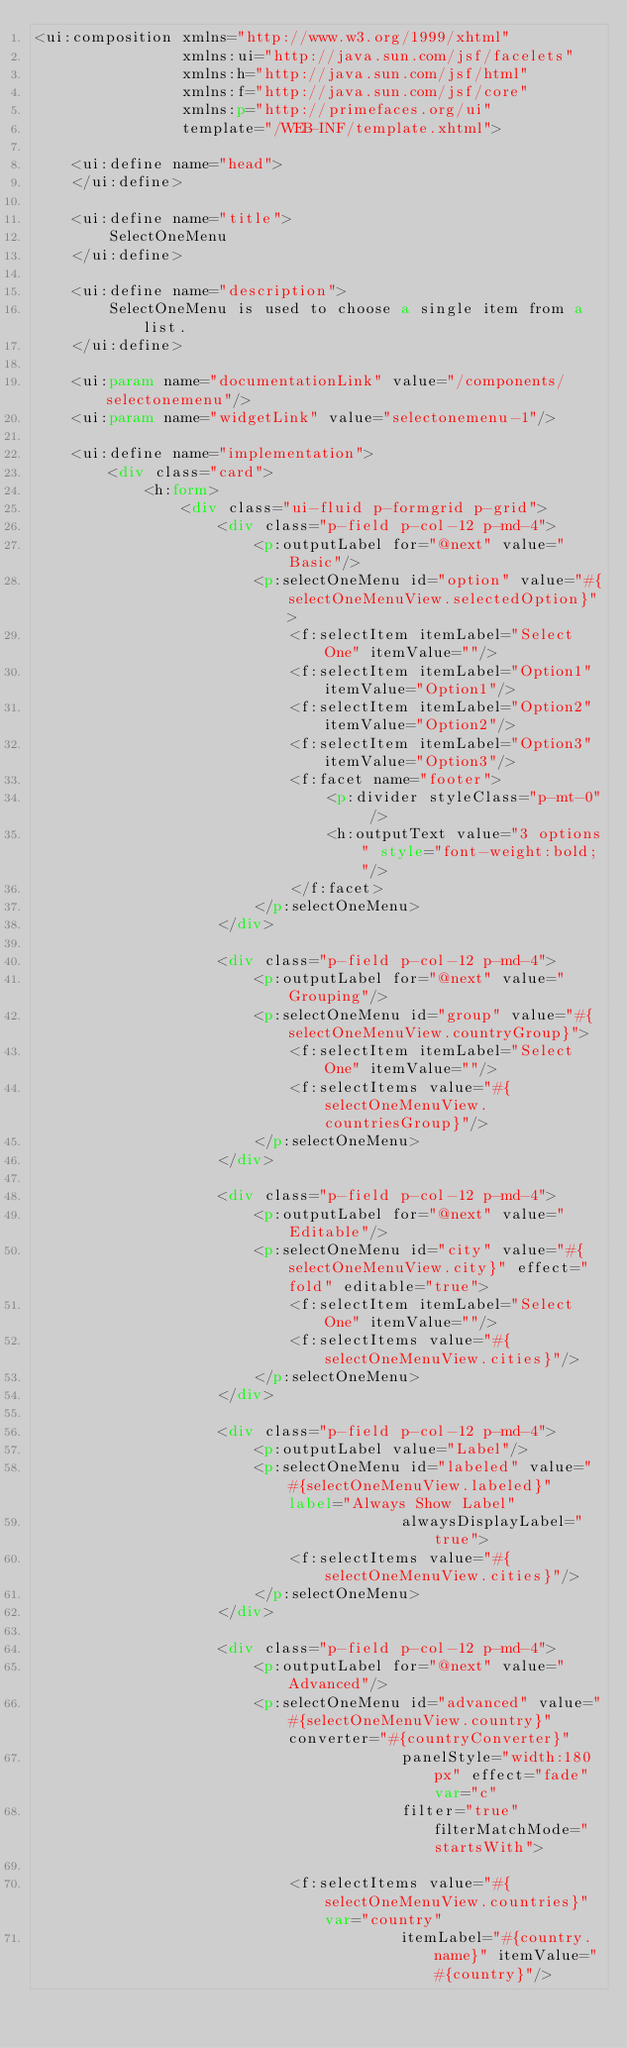Convert code to text. <code><loc_0><loc_0><loc_500><loc_500><_HTML_><ui:composition xmlns="http://www.w3.org/1999/xhtml"
                xmlns:ui="http://java.sun.com/jsf/facelets"
                xmlns:h="http://java.sun.com/jsf/html"
                xmlns:f="http://java.sun.com/jsf/core"
                xmlns:p="http://primefaces.org/ui"
                template="/WEB-INF/template.xhtml">

    <ui:define name="head">
    </ui:define>

    <ui:define name="title">
        SelectOneMenu
    </ui:define>

    <ui:define name="description">
        SelectOneMenu is used to choose a single item from a list.
    </ui:define>

    <ui:param name="documentationLink" value="/components/selectonemenu"/>
    <ui:param name="widgetLink" value="selectonemenu-1"/>

    <ui:define name="implementation">
        <div class="card">
            <h:form>
                <div class="ui-fluid p-formgrid p-grid">
                    <div class="p-field p-col-12 p-md-4">
                        <p:outputLabel for="@next" value="Basic"/>
                        <p:selectOneMenu id="option" value="#{selectOneMenuView.selectedOption}">
                            <f:selectItem itemLabel="Select One" itemValue=""/>
                            <f:selectItem itemLabel="Option1" itemValue="Option1"/>
                            <f:selectItem itemLabel="Option2" itemValue="Option2"/>
                            <f:selectItem itemLabel="Option3" itemValue="Option3"/>
                            <f:facet name="footer">
                                <p:divider styleClass="p-mt-0" />
                                <h:outputText value="3 options" style="font-weight:bold;"/>
                            </f:facet>
                        </p:selectOneMenu>
                    </div>

                    <div class="p-field p-col-12 p-md-4">
                        <p:outputLabel for="@next" value="Grouping"/>
                        <p:selectOneMenu id="group" value="#{selectOneMenuView.countryGroup}">
                            <f:selectItem itemLabel="Select One" itemValue=""/>
                            <f:selectItems value="#{selectOneMenuView.countriesGroup}"/>
                        </p:selectOneMenu>
                    </div>

                    <div class="p-field p-col-12 p-md-4">
                        <p:outputLabel for="@next" value="Editable"/>
                        <p:selectOneMenu id="city" value="#{selectOneMenuView.city}" effect="fold" editable="true">
                            <f:selectItem itemLabel="Select One" itemValue=""/>
                            <f:selectItems value="#{selectOneMenuView.cities}"/>
                        </p:selectOneMenu>
                    </div>

                    <div class="p-field p-col-12 p-md-4">
                        <p:outputLabel value="Label"/>
                        <p:selectOneMenu id="labeled" value="#{selectOneMenuView.labeled}" label="Always Show Label"
                                        alwaysDisplayLabel="true">
                            <f:selectItems value="#{selectOneMenuView.cities}"/>
                        </p:selectOneMenu>
                    </div>

                    <div class="p-field p-col-12 p-md-4">
                        <p:outputLabel for="@next" value="Advanced"/>
                        <p:selectOneMenu id="advanced" value="#{selectOneMenuView.country}" converter="#{countryConverter}"
                                        panelStyle="width:180px" effect="fade" var="c"
                                        filter="true" filterMatchMode="startsWith">

                            <f:selectItems value="#{selectOneMenuView.countries}" var="country"
                                        itemLabel="#{country.name}" itemValue="#{country}"/>
</code> 